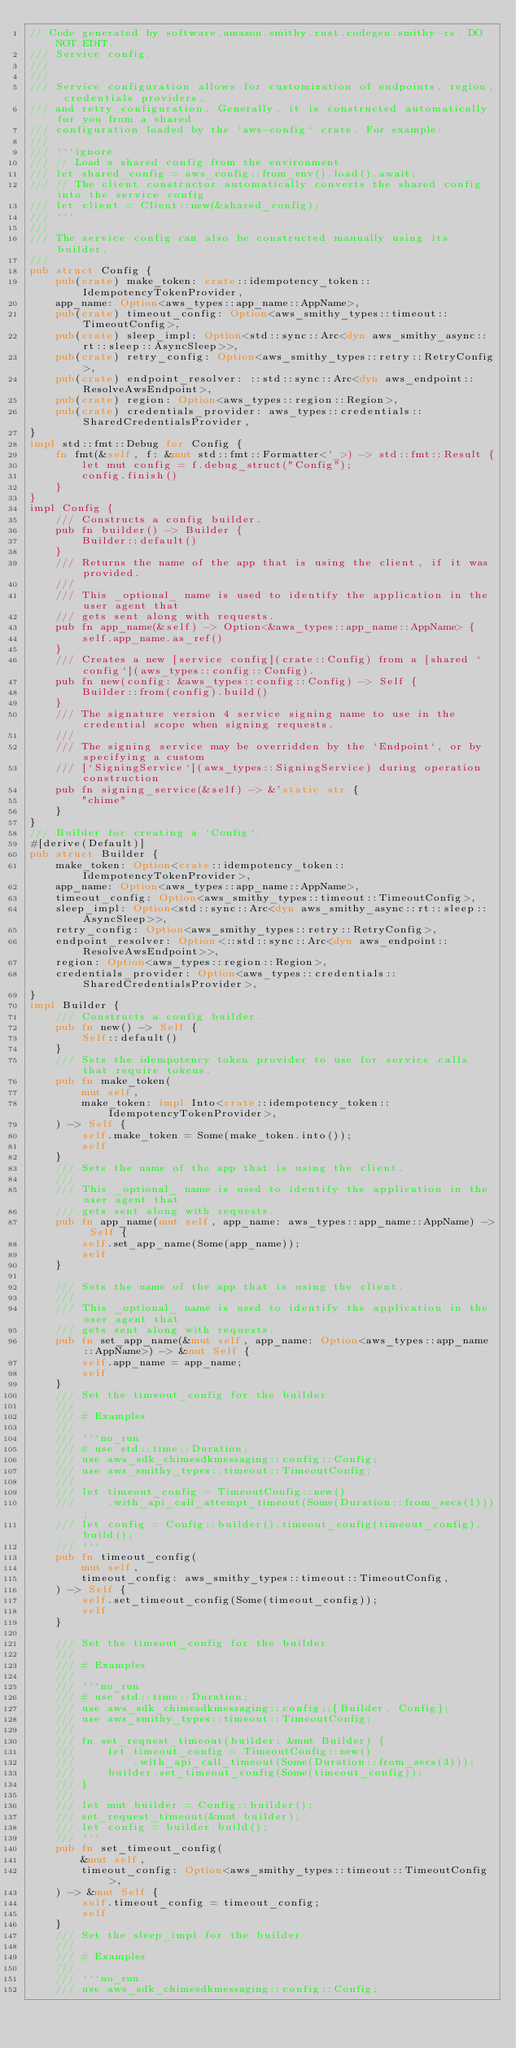<code> <loc_0><loc_0><loc_500><loc_500><_Rust_>// Code generated by software.amazon.smithy.rust.codegen.smithy-rs. DO NOT EDIT.
/// Service config.
///
///
/// Service configuration allows for customization of endpoints, region, credentials providers,
/// and retry configuration. Generally, it is constructed automatically for you from a shared
/// configuration loaded by the `aws-config` crate. For example:
///
/// ```ignore
/// // Load a shared config from the environment
/// let shared_config = aws_config::from_env().load().await;
/// // The client constructor automatically converts the shared config into the service config
/// let client = Client::new(&shared_config);
/// ```
///
/// The service config can also be constructed manually using its builder.
///
pub struct Config {
    pub(crate) make_token: crate::idempotency_token::IdempotencyTokenProvider,
    app_name: Option<aws_types::app_name::AppName>,
    pub(crate) timeout_config: Option<aws_smithy_types::timeout::TimeoutConfig>,
    pub(crate) sleep_impl: Option<std::sync::Arc<dyn aws_smithy_async::rt::sleep::AsyncSleep>>,
    pub(crate) retry_config: Option<aws_smithy_types::retry::RetryConfig>,
    pub(crate) endpoint_resolver: ::std::sync::Arc<dyn aws_endpoint::ResolveAwsEndpoint>,
    pub(crate) region: Option<aws_types::region::Region>,
    pub(crate) credentials_provider: aws_types::credentials::SharedCredentialsProvider,
}
impl std::fmt::Debug for Config {
    fn fmt(&self, f: &mut std::fmt::Formatter<'_>) -> std::fmt::Result {
        let mut config = f.debug_struct("Config");
        config.finish()
    }
}
impl Config {
    /// Constructs a config builder.
    pub fn builder() -> Builder {
        Builder::default()
    }
    /// Returns the name of the app that is using the client, if it was provided.
    ///
    /// This _optional_ name is used to identify the application in the user agent that
    /// gets sent along with requests.
    pub fn app_name(&self) -> Option<&aws_types::app_name::AppName> {
        self.app_name.as_ref()
    }
    /// Creates a new [service config](crate::Config) from a [shared `config`](aws_types::config::Config).
    pub fn new(config: &aws_types::config::Config) -> Self {
        Builder::from(config).build()
    }
    /// The signature version 4 service signing name to use in the credential scope when signing requests.
    ///
    /// The signing service may be overridden by the `Endpoint`, or by specifying a custom
    /// [`SigningService`](aws_types::SigningService) during operation construction
    pub fn signing_service(&self) -> &'static str {
        "chime"
    }
}
/// Builder for creating a `Config`.
#[derive(Default)]
pub struct Builder {
    make_token: Option<crate::idempotency_token::IdempotencyTokenProvider>,
    app_name: Option<aws_types::app_name::AppName>,
    timeout_config: Option<aws_smithy_types::timeout::TimeoutConfig>,
    sleep_impl: Option<std::sync::Arc<dyn aws_smithy_async::rt::sleep::AsyncSleep>>,
    retry_config: Option<aws_smithy_types::retry::RetryConfig>,
    endpoint_resolver: Option<::std::sync::Arc<dyn aws_endpoint::ResolveAwsEndpoint>>,
    region: Option<aws_types::region::Region>,
    credentials_provider: Option<aws_types::credentials::SharedCredentialsProvider>,
}
impl Builder {
    /// Constructs a config builder.
    pub fn new() -> Self {
        Self::default()
    }
    /// Sets the idempotency token provider to use for service calls that require tokens.
    pub fn make_token(
        mut self,
        make_token: impl Into<crate::idempotency_token::IdempotencyTokenProvider>,
    ) -> Self {
        self.make_token = Some(make_token.into());
        self
    }
    /// Sets the name of the app that is using the client.
    ///
    /// This _optional_ name is used to identify the application in the user agent that
    /// gets sent along with requests.
    pub fn app_name(mut self, app_name: aws_types::app_name::AppName) -> Self {
        self.set_app_name(Some(app_name));
        self
    }

    /// Sets the name of the app that is using the client.
    ///
    /// This _optional_ name is used to identify the application in the user agent that
    /// gets sent along with requests.
    pub fn set_app_name(&mut self, app_name: Option<aws_types::app_name::AppName>) -> &mut Self {
        self.app_name = app_name;
        self
    }
    /// Set the timeout_config for the builder
    ///
    /// # Examples
    ///
    /// ```no_run
    /// # use std::time::Duration;
    /// use aws_sdk_chimesdkmessaging::config::Config;
    /// use aws_smithy_types::timeout::TimeoutConfig;
    ///
    /// let timeout_config = TimeoutConfig::new()
    ///     .with_api_call_attempt_timeout(Some(Duration::from_secs(1)));
    /// let config = Config::builder().timeout_config(timeout_config).build();
    /// ```
    pub fn timeout_config(
        mut self,
        timeout_config: aws_smithy_types::timeout::TimeoutConfig,
    ) -> Self {
        self.set_timeout_config(Some(timeout_config));
        self
    }

    /// Set the timeout_config for the builder
    ///
    /// # Examples
    ///
    /// ```no_run
    /// # use std::time::Duration;
    /// use aws_sdk_chimesdkmessaging::config::{Builder, Config};
    /// use aws_smithy_types::timeout::TimeoutConfig;
    ///
    /// fn set_request_timeout(builder: &mut Builder) {
    ///     let timeout_config = TimeoutConfig::new()
    ///         .with_api_call_timeout(Some(Duration::from_secs(3)));
    ///     builder.set_timeout_config(Some(timeout_config));
    /// }
    ///
    /// let mut builder = Config::builder();
    /// set_request_timeout(&mut builder);
    /// let config = builder.build();
    /// ```
    pub fn set_timeout_config(
        &mut self,
        timeout_config: Option<aws_smithy_types::timeout::TimeoutConfig>,
    ) -> &mut Self {
        self.timeout_config = timeout_config;
        self
    }
    /// Set the sleep_impl for the builder
    ///
    /// # Examples
    ///
    /// ```no_run
    /// use aws_sdk_chimesdkmessaging::config::Config;</code> 